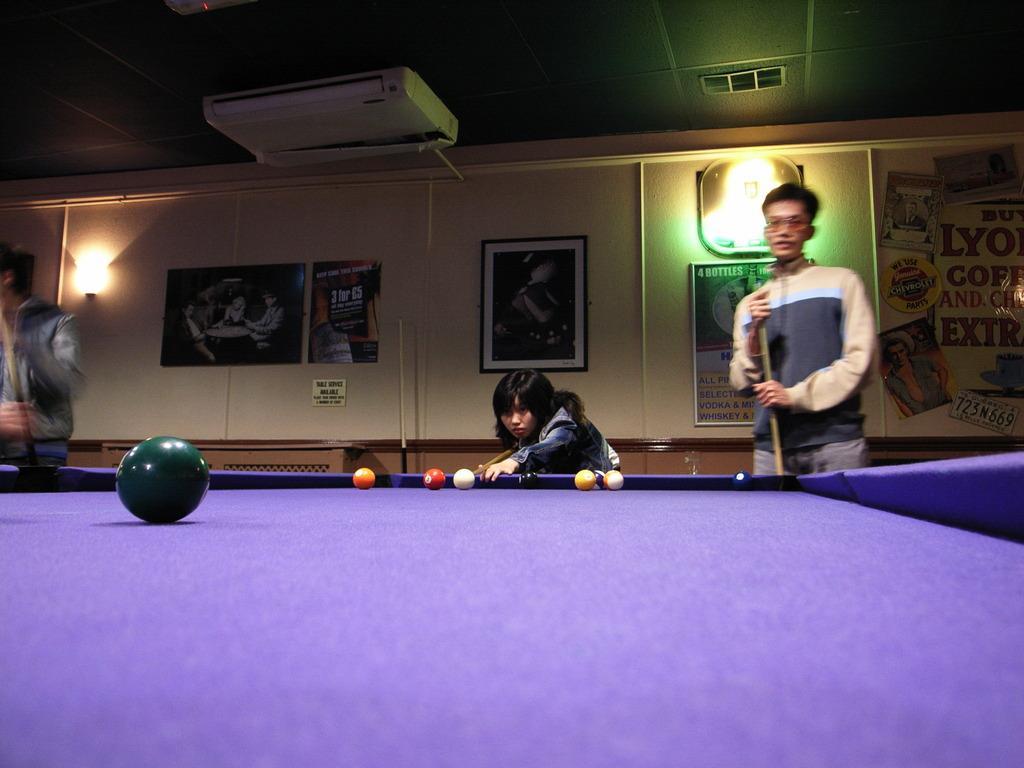Could you give a brief overview of what you see in this image? In the center we can see two persons were standing and holding stick. In the bottom we can see table on table we can see balls. Coming to the background we can see wall and photo frames. 